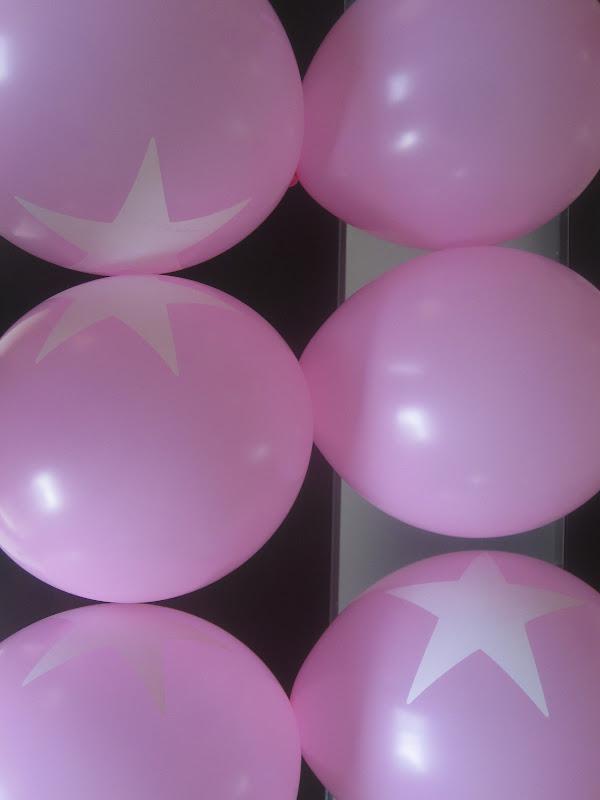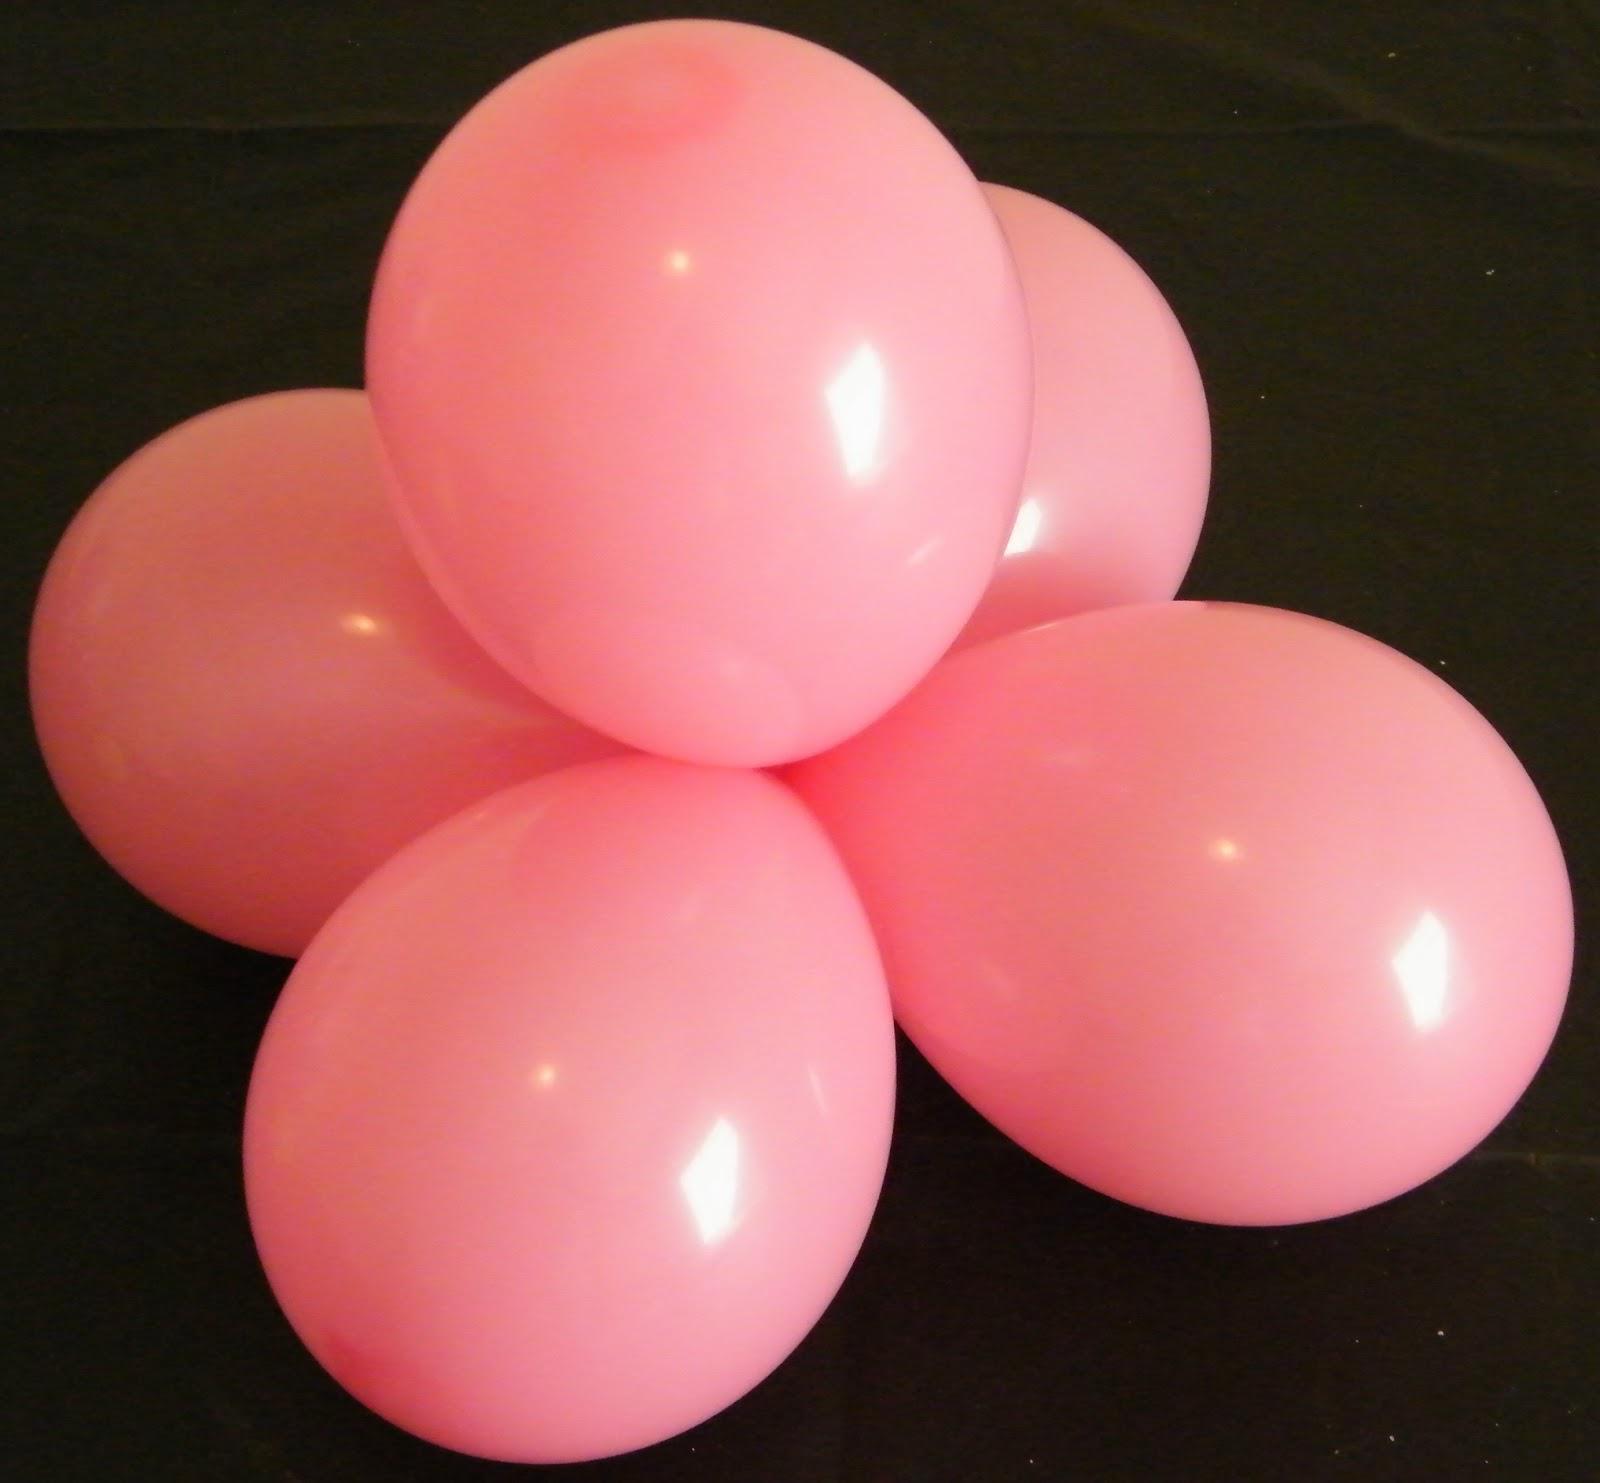The first image is the image on the left, the second image is the image on the right. For the images shown, is this caption "There are no more than three balloons in each image." true? Answer yes or no. No. The first image is the image on the left, the second image is the image on the right. Assess this claim about the two images: "AN image shows at least three blue balloons displayed with knot ends joined at the center.". Correct or not? Answer yes or no. No. 